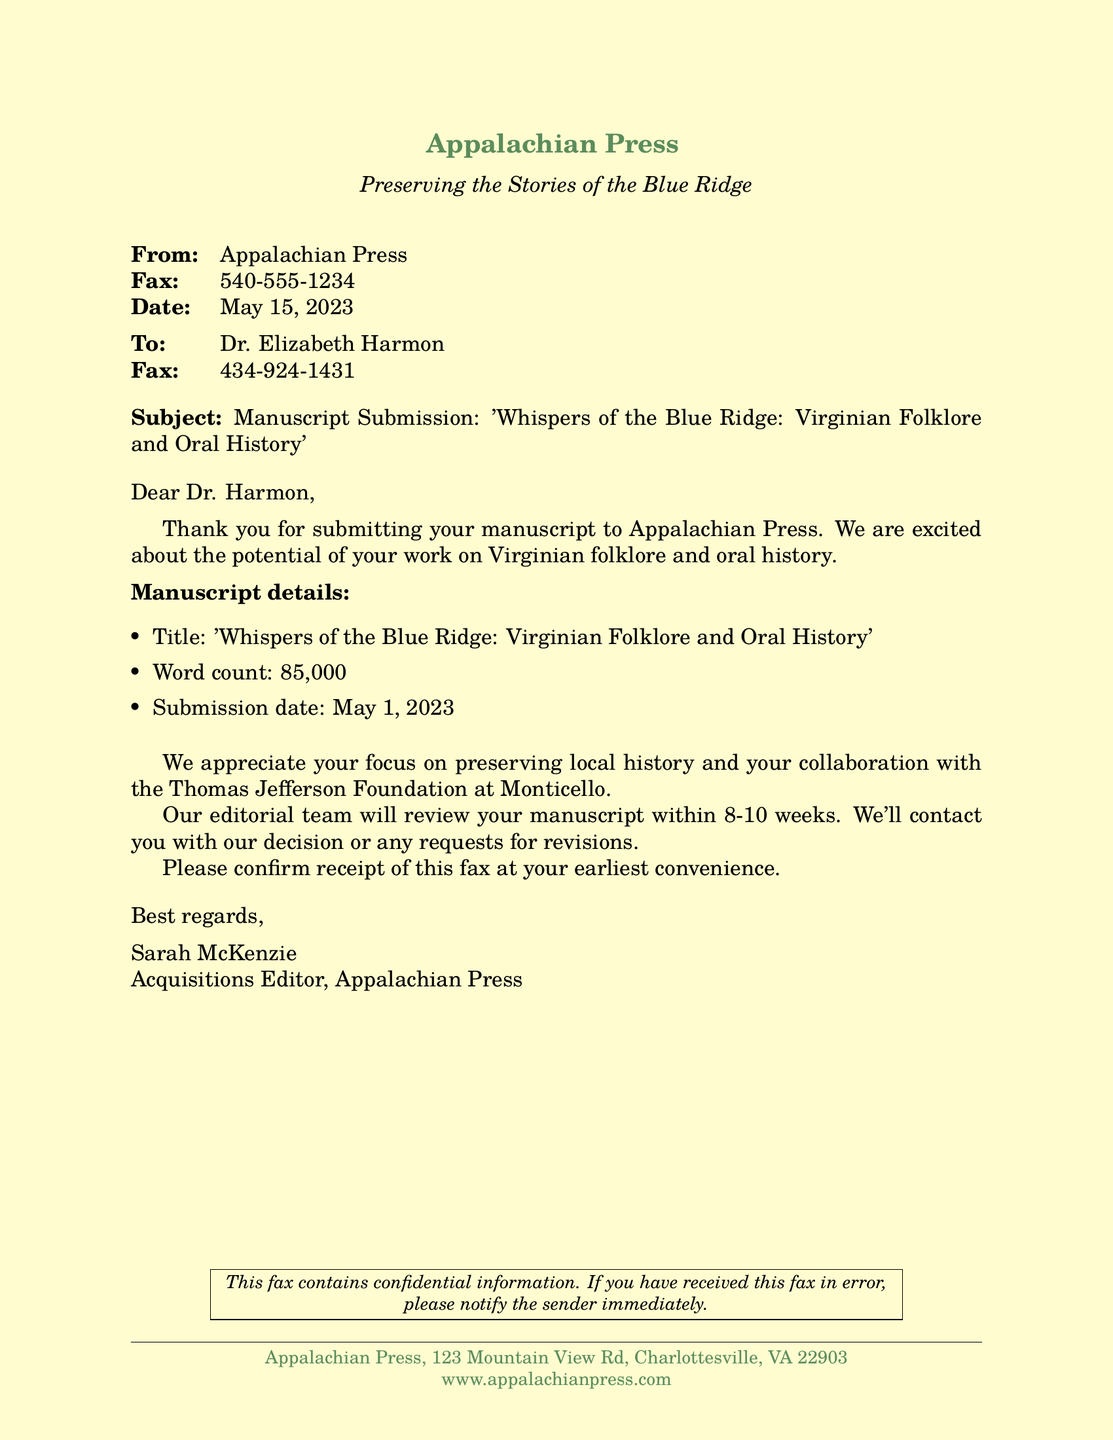What is the name of the publisher? The publisher is named Appalachian Press, as indicated in the header of the fax.
Answer: Appalachian Press Who is the Acquisitions Editor? The Acquisitions Editor is mentioned as Sarah McKenzie at the bottom of the fax.
Answer: Sarah McKenzie What is the title of the submitted manuscript? The title of the manuscript is stated in the subject line of the fax.
Answer: 'Whispers of the Blue Ridge: Virginian Folklore and Oral History' What is the word count of the manuscript? The document specifies that the word count is listed in the manuscript details section.
Answer: 85,000 When was the manuscript submitted? The submission date is included in the manuscript details of the fax.
Answer: May 1, 2023 How long will the review process take? The fax states that the review process will take place within a specific time frame.
Answer: 8-10 weeks What should Dr. Harmon confirm? The letter requests Dr. Harmon to confirm a specific action related to the fax.
Answer: Receipt of this fax What collaboration is mentioned in the fax? The fax notes a particular collaboration related to local history preservation.
Answer: Thomas Jefferson Foundation at Monticello What is the primary focus of the manuscript? The focus of the manuscript is indicated in the introductory paragraph of the fax.
Answer: Preserving local history 